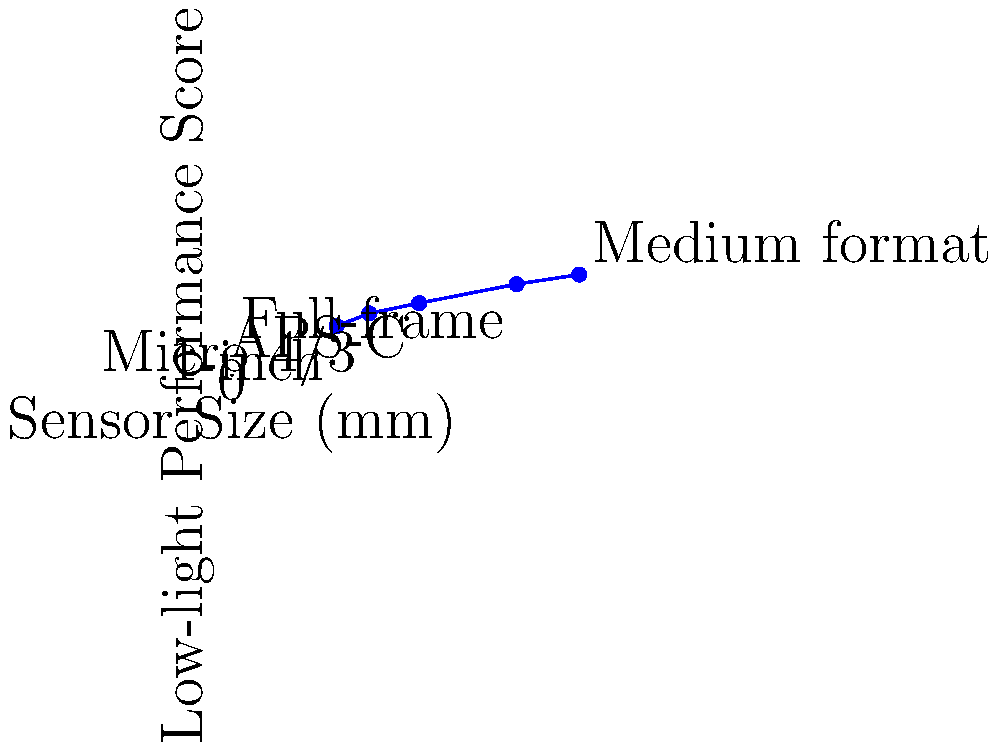Based on the graph showing the relationship between camera sensor sizes and low-light performance scores, which sensor size would you recommend for a travel blogger who frequently captures nighttime cityscapes and wants to minimize image noise? To answer this question, let's analyze the graph step-by-step:

1. The x-axis shows different sensor sizes in millimeters, ranging from smaller sensors (left) to larger sensors (right).
2. The y-axis represents the low-light performance score, with higher scores indicating better performance in low-light conditions.
3. We can see a clear positive correlation between sensor size and low-light performance.
4. The graph shows five common sensor sizes:
   - 1-inch (13.2mm): Score of 6.2
   - Micro 4/3 (17.3mm): Score of 7.8
   - APS-C (23.6mm): Score of 9.1
   - Full-frame (35.9mm): Score of 11.5
   - Medium format (43.8mm): Score of 12.7

5. For nighttime cityscapes, better low-light performance is crucial to minimize image noise.
6. The full-frame sensor (35.9mm) offers a significantly higher low-light performance score (11.5) compared to smaller sensors.
7. While the medium format sensor has the highest score (12.7), it's typically found in more expensive, specialized cameras that may not be as practical for travel blogging.

Considering the balance between performance and practicality for a travel blogger, the full-frame sensor would be the most suitable recommendation. It offers excellent low-light performance without the extra bulk and cost associated with medium format cameras.
Answer: Full-frame sensor 